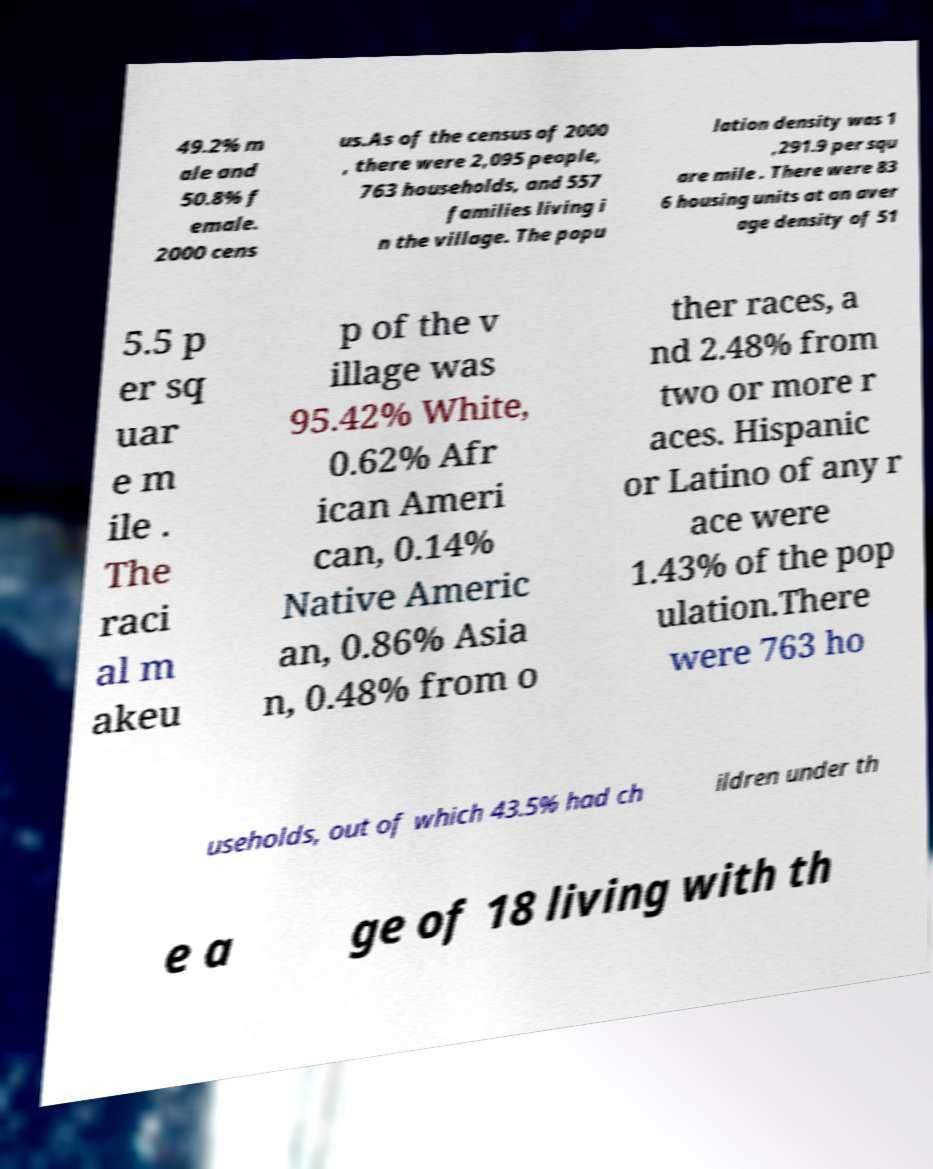There's text embedded in this image that I need extracted. Can you transcribe it verbatim? 49.2% m ale and 50.8% f emale. 2000 cens us.As of the census of 2000 , there were 2,095 people, 763 households, and 557 families living i n the village. The popu lation density was 1 ,291.9 per squ are mile . There were 83 6 housing units at an aver age density of 51 5.5 p er sq uar e m ile . The raci al m akeu p of the v illage was 95.42% White, 0.62% Afr ican Ameri can, 0.14% Native Americ an, 0.86% Asia n, 0.48% from o ther races, a nd 2.48% from two or more r aces. Hispanic or Latino of any r ace were 1.43% of the pop ulation.There were 763 ho useholds, out of which 43.5% had ch ildren under th e a ge of 18 living with th 